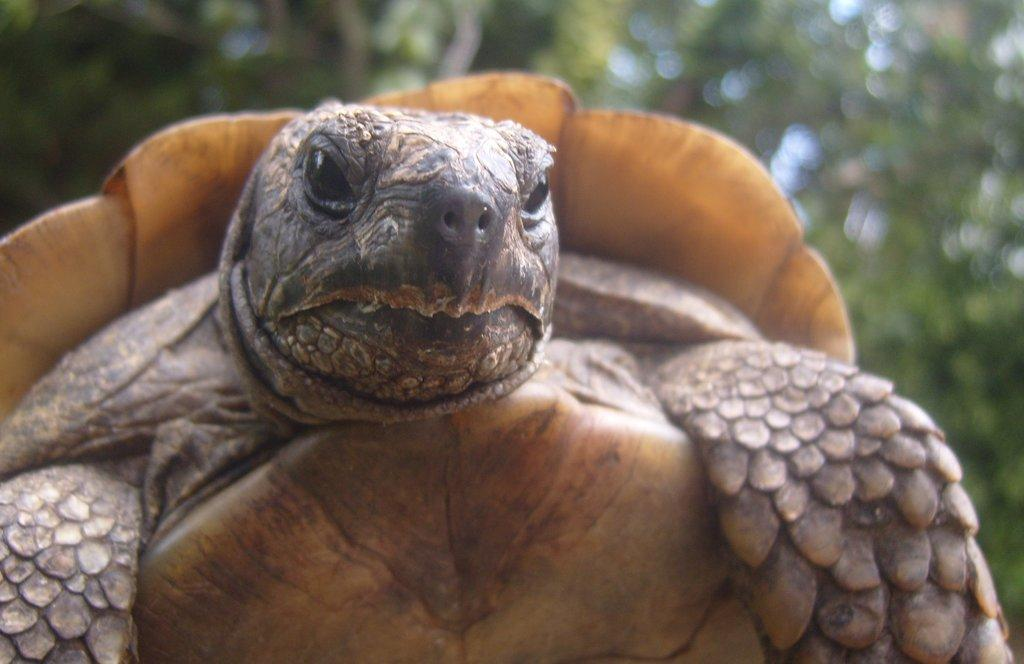What is the main subject in the foreground of the image? There is a turtle in the foreground of the image. What can be seen in the background of the image? There are trees in the background of the image. What type of lead is the turtle using to climb the tree in the image? There is no lead present in the image, and the turtle is not climbing a tree. 